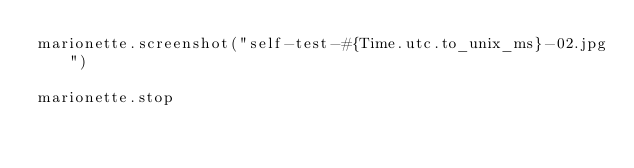Convert code to text. <code><loc_0><loc_0><loc_500><loc_500><_Crystal_>marionette.screenshot("self-test-#{Time.utc.to_unix_ms}-02.jpg")

marionette.stop
</code> 